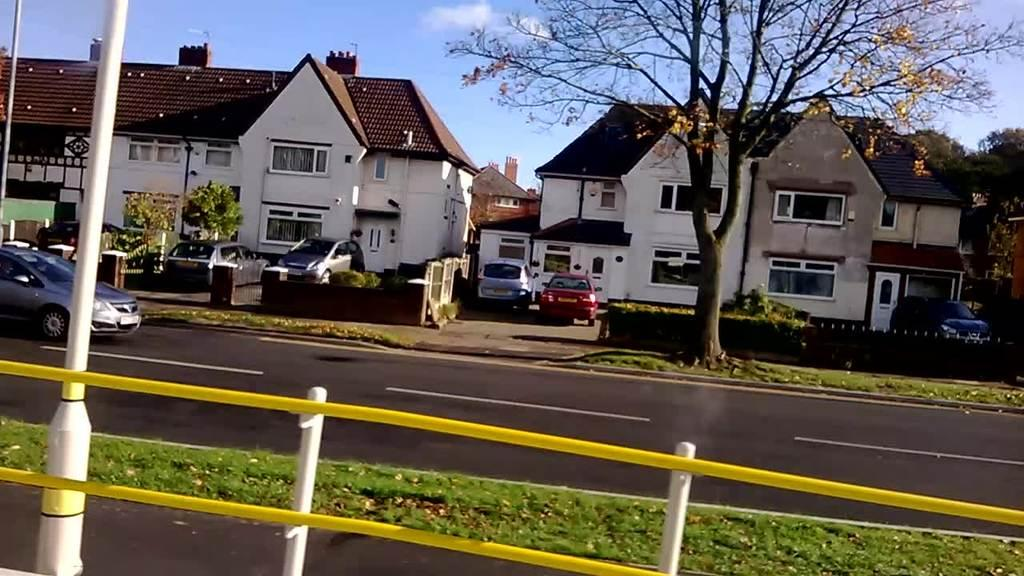What type of structure can be seen in the image? There is a fencing in the image. What is located near the fencing? There is a pole in the image. What is visible behind the fencing? There is a road behind the fencing. What is on the road? There is a car on the road. What can be seen in the background of the image? There are houses, cars, trees, and the sky visible in the background of the image. What type of produce is being rewarded with a quarter in the image? There is no produce or quarter present in the image. 